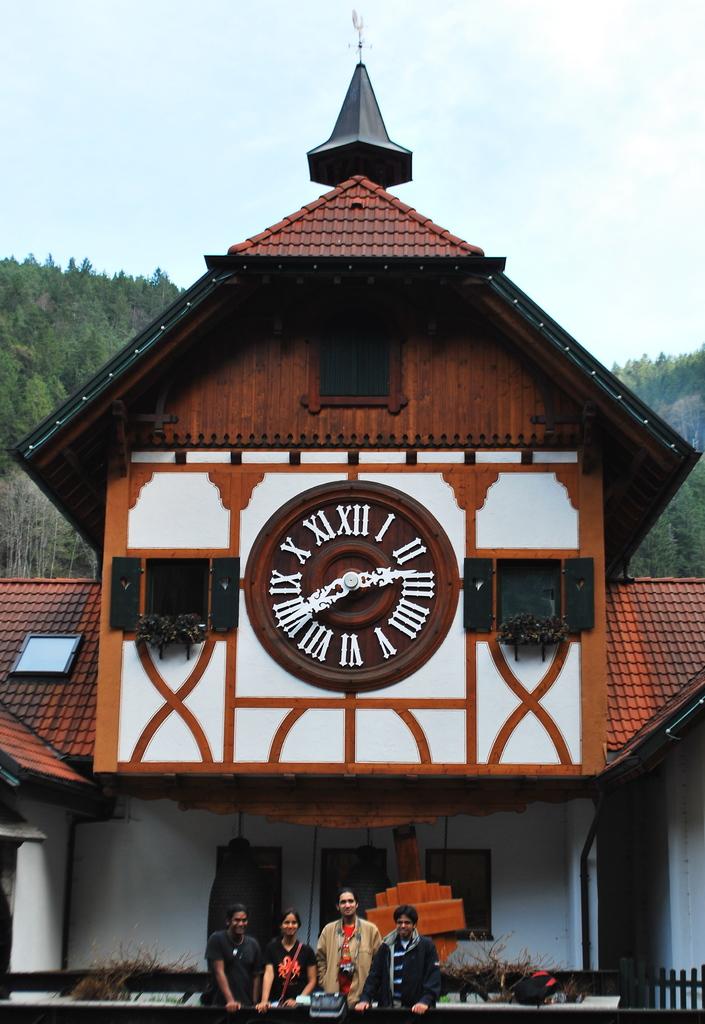What time is it?
Make the answer very short. 2:40. 